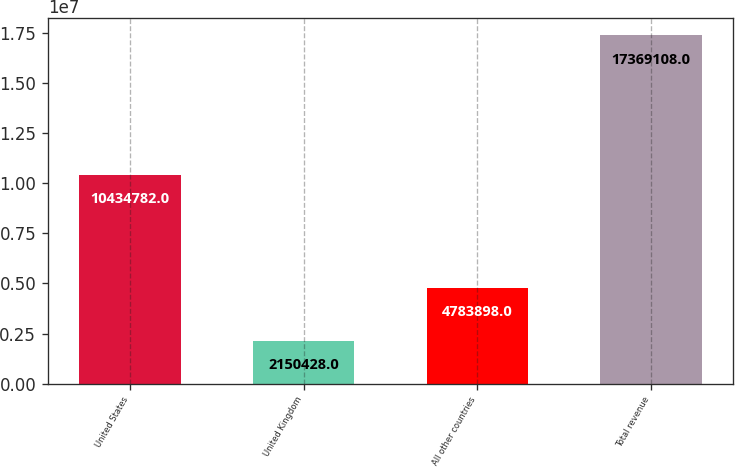Convert chart. <chart><loc_0><loc_0><loc_500><loc_500><bar_chart><fcel>United States<fcel>United Kingdom<fcel>All other countries<fcel>Total revenue<nl><fcel>1.04348e+07<fcel>2.15043e+06<fcel>4.7839e+06<fcel>1.73691e+07<nl></chart> 